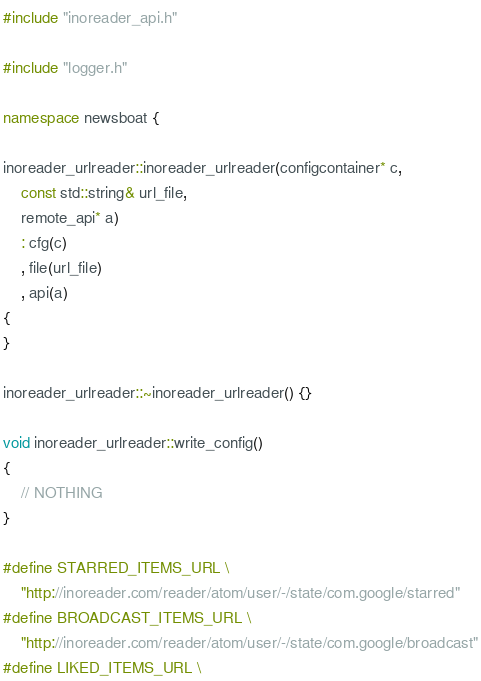Convert code to text. <code><loc_0><loc_0><loc_500><loc_500><_C++_>#include "inoreader_api.h"

#include "logger.h"

namespace newsboat {

inoreader_urlreader::inoreader_urlreader(configcontainer* c,
	const std::string& url_file,
	remote_api* a)
	: cfg(c)
	, file(url_file)
	, api(a)
{
}

inoreader_urlreader::~inoreader_urlreader() {}

void inoreader_urlreader::write_config()
{
	// NOTHING
}

#define STARRED_ITEMS_URL \
	"http://inoreader.com/reader/atom/user/-/state/com.google/starred"
#define BROADCAST_ITEMS_URL \
	"http://inoreader.com/reader/atom/user/-/state/com.google/broadcast"
#define LIKED_ITEMS_URL \</code> 